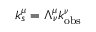<formula> <loc_0><loc_0><loc_500><loc_500>k _ { s } ^ { \mu } = \Lambda _ { \nu } ^ { \mu } k _ { o b s } ^ { \nu }</formula> 